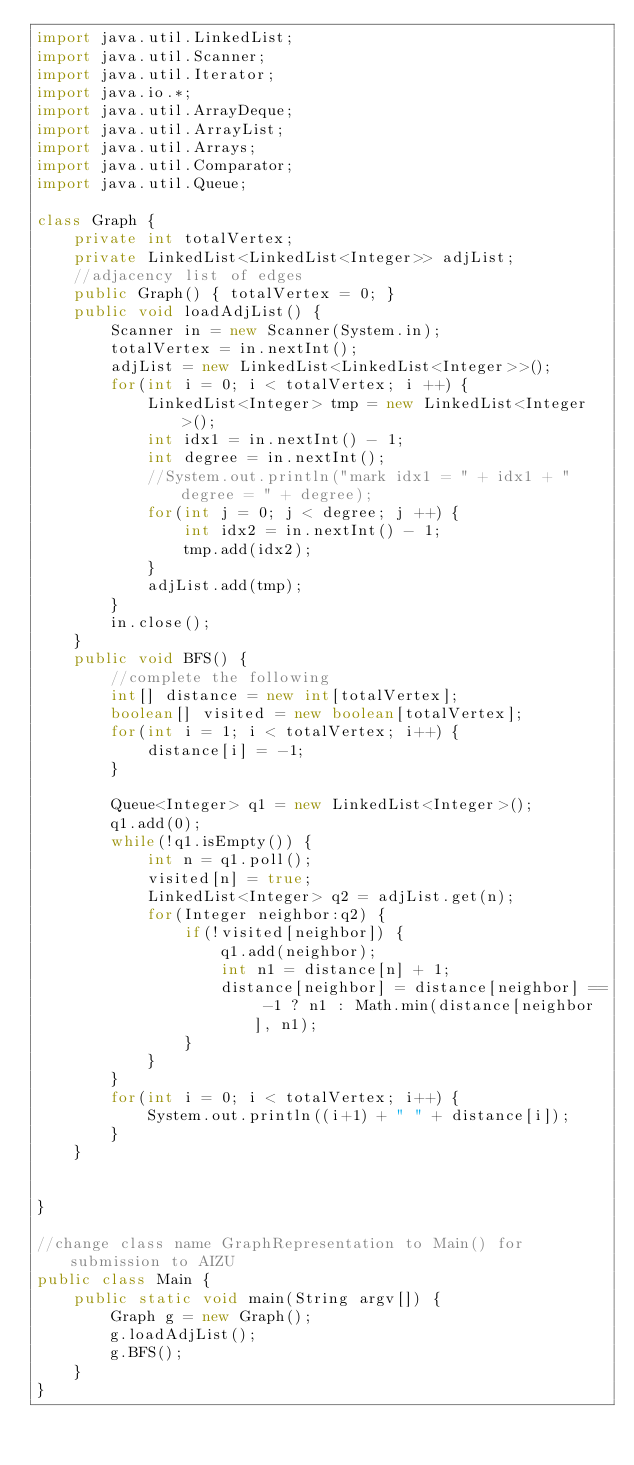<code> <loc_0><loc_0><loc_500><loc_500><_Java_>import java.util.LinkedList;
import java.util.Scanner;
import java.util.Iterator;
import java.io.*;
import java.util.ArrayDeque;
import java.util.ArrayList;
import java.util.Arrays;
import java.util.Comparator;
import java.util.Queue;

class Graph {
	private int totalVertex;
	private LinkedList<LinkedList<Integer>> adjList;
	//adjacency list of edges
	public Graph() { totalVertex = 0; }
	public void loadAdjList() {
		Scanner in = new Scanner(System.in);
		totalVertex = in.nextInt();
		adjList = new LinkedList<LinkedList<Integer>>();
		for(int i = 0; i < totalVertex; i ++) {
			LinkedList<Integer> tmp = new LinkedList<Integer>();
			int idx1 = in.nextInt() - 1;
			int degree = in.nextInt();
			//System.out.println("mark idx1 = " + idx1 + " degree = " + degree);
			for(int j = 0; j < degree; j ++) {
				int idx2 = in.nextInt() - 1;
				tmp.add(idx2);
			}	
			adjList.add(tmp);
		}
		in.close();
	}
	public void BFS() {
		//complete the following
		int[] distance = new int[totalVertex];
		boolean[] visited = new boolean[totalVertex];
		for(int i = 1; i < totalVertex; i++) {
			distance[i] = -1;
		}
		
		Queue<Integer> q1 = new LinkedList<Integer>();
		q1.add(0);
		while(!q1.isEmpty()) {
			int n = q1.poll();
			visited[n] = true;
			LinkedList<Integer> q2 = adjList.get(n);
			for(Integer neighbor:q2) {
				if(!visited[neighbor]) {
					q1.add(neighbor);
					int n1 = distance[n] + 1;
					distance[neighbor] = distance[neighbor] == -1 ? n1 : Math.min(distance[neighbor], n1);
				}
			}
		}
		for(int i = 0; i < totalVertex; i++) {
			System.out.println((i+1) + " " + distance[i]);
		}
	}
	
	
}

//change class name GraphRepresentation to Main() for submission to AIZU
public class Main {
	public static void main(String argv[]) {
		Graph g = new Graph();
		g.loadAdjList();
		g.BFS();
	}
}

</code> 